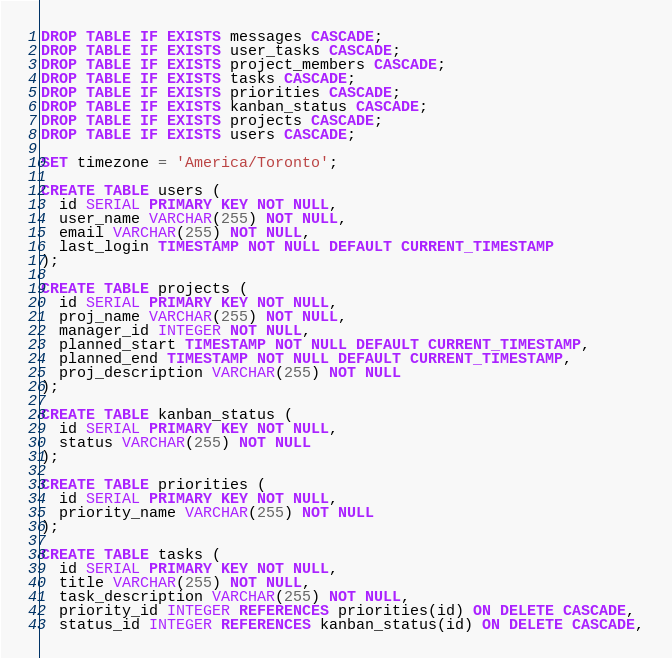<code> <loc_0><loc_0><loc_500><loc_500><_SQL_>DROP TABLE IF EXISTS messages CASCADE;
DROP TABLE IF EXISTS user_tasks CASCADE;
DROP TABLE IF EXISTS project_members CASCADE;
DROP TABLE IF EXISTS tasks CASCADE;
DROP TABLE IF EXISTS priorities CASCADE;
DROP TABLE IF EXISTS kanban_status CASCADE;
DROP TABLE IF EXISTS projects CASCADE;
DROP TABLE IF EXISTS users CASCADE;

SET timezone = 'America/Toronto';

CREATE TABLE users (
  id SERIAL PRIMARY KEY NOT NULL,
  user_name VARCHAR(255) NOT NULL,
  email VARCHAR(255) NOT NULL,
  last_login TIMESTAMP NOT NULL DEFAULT CURRENT_TIMESTAMP
);

CREATE TABLE projects (
  id SERIAL PRIMARY KEY NOT NULL,
  proj_name VARCHAR(255) NOT NULL,
  manager_id INTEGER NOT NULL,
  planned_start TIMESTAMP NOT NULL DEFAULT CURRENT_TIMESTAMP,
  planned_end TIMESTAMP NOT NULL DEFAULT CURRENT_TIMESTAMP,
  proj_description VARCHAR(255) NOT NULL
);

CREATE TABLE kanban_status (
  id SERIAL PRIMARY KEY NOT NULL,
  status VARCHAR(255) NOT NULL
);

CREATE TABLE priorities (
  id SERIAL PRIMARY KEY NOT NULL,
  priority_name VARCHAR(255) NOT NULL
);

CREATE TABLE tasks (
  id SERIAL PRIMARY KEY NOT NULL,
  title VARCHAR(255) NOT NULL,
  task_description VARCHAR(255) NOT NULL,
  priority_id INTEGER REFERENCES priorities(id) ON DELETE CASCADE,
  status_id INTEGER REFERENCES kanban_status(id) ON DELETE CASCADE,</code> 